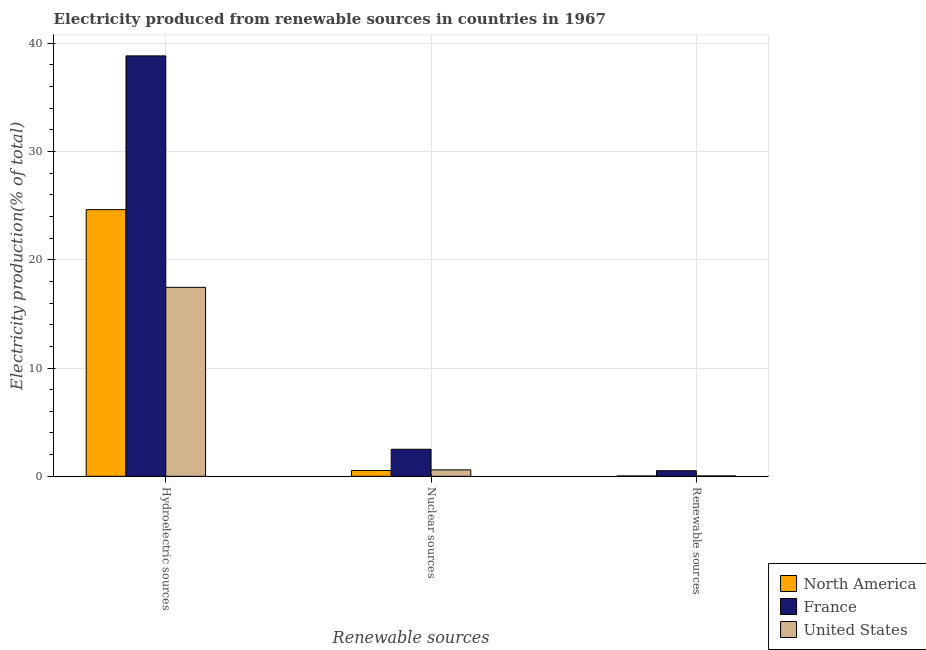Are the number of bars on each tick of the X-axis equal?
Offer a terse response. Yes. What is the label of the 2nd group of bars from the left?
Offer a very short reply. Nuclear sources. What is the percentage of electricity produced by nuclear sources in United States?
Provide a short and direct response. 0.59. Across all countries, what is the maximum percentage of electricity produced by nuclear sources?
Provide a short and direct response. 2.5. Across all countries, what is the minimum percentage of electricity produced by renewable sources?
Offer a terse response. 0.03. In which country was the percentage of electricity produced by nuclear sources minimum?
Offer a very short reply. North America. What is the total percentage of electricity produced by renewable sources in the graph?
Provide a short and direct response. 0.59. What is the difference between the percentage of electricity produced by renewable sources in United States and that in France?
Offer a very short reply. -0.48. What is the difference between the percentage of electricity produced by hydroelectric sources in United States and the percentage of electricity produced by nuclear sources in France?
Ensure brevity in your answer.  14.95. What is the average percentage of electricity produced by nuclear sources per country?
Give a very brief answer. 1.21. What is the difference between the percentage of electricity produced by renewable sources and percentage of electricity produced by nuclear sources in United States?
Provide a short and direct response. -0.56. What is the ratio of the percentage of electricity produced by hydroelectric sources in North America to that in United States?
Offer a very short reply. 1.41. Is the difference between the percentage of electricity produced by nuclear sources in United States and North America greater than the difference between the percentage of electricity produced by renewable sources in United States and North America?
Your response must be concise. Yes. What is the difference between the highest and the second highest percentage of electricity produced by hydroelectric sources?
Your response must be concise. 14.2. What is the difference between the highest and the lowest percentage of electricity produced by renewable sources?
Offer a very short reply. 0.49. In how many countries, is the percentage of electricity produced by hydroelectric sources greater than the average percentage of electricity produced by hydroelectric sources taken over all countries?
Provide a succinct answer. 1. What does the 1st bar from the right in Hydroelectric sources represents?
Your answer should be very brief. United States. Are all the bars in the graph horizontal?
Provide a short and direct response. No. What is the difference between two consecutive major ticks on the Y-axis?
Your answer should be very brief. 10. Does the graph contain any zero values?
Ensure brevity in your answer.  No. How are the legend labels stacked?
Give a very brief answer. Vertical. What is the title of the graph?
Keep it short and to the point. Electricity produced from renewable sources in countries in 1967. Does "Malawi" appear as one of the legend labels in the graph?
Ensure brevity in your answer.  No. What is the label or title of the X-axis?
Offer a terse response. Renewable sources. What is the Electricity production(% of total) in North America in Hydroelectric sources?
Provide a succinct answer. 24.62. What is the Electricity production(% of total) in France in Hydroelectric sources?
Offer a terse response. 38.81. What is the Electricity production(% of total) in United States in Hydroelectric sources?
Provide a short and direct response. 17.45. What is the Electricity production(% of total) in North America in Nuclear sources?
Your response must be concise. 0.54. What is the Electricity production(% of total) in France in Nuclear sources?
Your answer should be compact. 2.5. What is the Electricity production(% of total) in United States in Nuclear sources?
Offer a terse response. 0.59. What is the Electricity production(% of total) in North America in Renewable sources?
Your answer should be compact. 0.03. What is the Electricity production(% of total) in France in Renewable sources?
Your answer should be compact. 0.52. What is the Electricity production(% of total) in United States in Renewable sources?
Provide a short and direct response. 0.04. Across all Renewable sources, what is the maximum Electricity production(% of total) in North America?
Keep it short and to the point. 24.62. Across all Renewable sources, what is the maximum Electricity production(% of total) in France?
Ensure brevity in your answer.  38.81. Across all Renewable sources, what is the maximum Electricity production(% of total) in United States?
Offer a terse response. 17.45. Across all Renewable sources, what is the minimum Electricity production(% of total) of North America?
Provide a succinct answer. 0.03. Across all Renewable sources, what is the minimum Electricity production(% of total) of France?
Give a very brief answer. 0.52. Across all Renewable sources, what is the minimum Electricity production(% of total) of United States?
Offer a very short reply. 0.04. What is the total Electricity production(% of total) in North America in the graph?
Offer a terse response. 25.19. What is the total Electricity production(% of total) of France in the graph?
Ensure brevity in your answer.  41.83. What is the total Electricity production(% of total) of United States in the graph?
Offer a terse response. 18.08. What is the difference between the Electricity production(% of total) of North America in Hydroelectric sources and that in Nuclear sources?
Your response must be concise. 24.08. What is the difference between the Electricity production(% of total) in France in Hydroelectric sources and that in Nuclear sources?
Make the answer very short. 36.32. What is the difference between the Electricity production(% of total) of United States in Hydroelectric sources and that in Nuclear sources?
Offer a very short reply. 16.85. What is the difference between the Electricity production(% of total) in North America in Hydroelectric sources and that in Renewable sources?
Offer a terse response. 24.59. What is the difference between the Electricity production(% of total) in France in Hydroelectric sources and that in Renewable sources?
Ensure brevity in your answer.  38.3. What is the difference between the Electricity production(% of total) of United States in Hydroelectric sources and that in Renewable sources?
Ensure brevity in your answer.  17.41. What is the difference between the Electricity production(% of total) of North America in Nuclear sources and that in Renewable sources?
Your answer should be compact. 0.5. What is the difference between the Electricity production(% of total) in France in Nuclear sources and that in Renewable sources?
Make the answer very short. 1.98. What is the difference between the Electricity production(% of total) in United States in Nuclear sources and that in Renewable sources?
Keep it short and to the point. 0.56. What is the difference between the Electricity production(% of total) of North America in Hydroelectric sources and the Electricity production(% of total) of France in Nuclear sources?
Your answer should be very brief. 22.12. What is the difference between the Electricity production(% of total) in North America in Hydroelectric sources and the Electricity production(% of total) in United States in Nuclear sources?
Your answer should be compact. 24.02. What is the difference between the Electricity production(% of total) of France in Hydroelectric sources and the Electricity production(% of total) of United States in Nuclear sources?
Offer a very short reply. 38.22. What is the difference between the Electricity production(% of total) in North America in Hydroelectric sources and the Electricity production(% of total) in France in Renewable sources?
Keep it short and to the point. 24.1. What is the difference between the Electricity production(% of total) in North America in Hydroelectric sources and the Electricity production(% of total) in United States in Renewable sources?
Provide a short and direct response. 24.58. What is the difference between the Electricity production(% of total) of France in Hydroelectric sources and the Electricity production(% of total) of United States in Renewable sources?
Keep it short and to the point. 38.78. What is the difference between the Electricity production(% of total) of North America in Nuclear sources and the Electricity production(% of total) of France in Renewable sources?
Provide a succinct answer. 0.02. What is the difference between the Electricity production(% of total) in North America in Nuclear sources and the Electricity production(% of total) in United States in Renewable sources?
Provide a succinct answer. 0.5. What is the difference between the Electricity production(% of total) of France in Nuclear sources and the Electricity production(% of total) of United States in Renewable sources?
Provide a succinct answer. 2.46. What is the average Electricity production(% of total) of North America per Renewable sources?
Give a very brief answer. 8.4. What is the average Electricity production(% of total) in France per Renewable sources?
Offer a terse response. 13.94. What is the average Electricity production(% of total) in United States per Renewable sources?
Keep it short and to the point. 6.03. What is the difference between the Electricity production(% of total) of North America and Electricity production(% of total) of France in Hydroelectric sources?
Provide a succinct answer. -14.2. What is the difference between the Electricity production(% of total) of North America and Electricity production(% of total) of United States in Hydroelectric sources?
Keep it short and to the point. 7.17. What is the difference between the Electricity production(% of total) of France and Electricity production(% of total) of United States in Hydroelectric sources?
Your answer should be very brief. 21.37. What is the difference between the Electricity production(% of total) of North America and Electricity production(% of total) of France in Nuclear sources?
Your answer should be very brief. -1.96. What is the difference between the Electricity production(% of total) of North America and Electricity production(% of total) of United States in Nuclear sources?
Your response must be concise. -0.06. What is the difference between the Electricity production(% of total) in France and Electricity production(% of total) in United States in Nuclear sources?
Offer a very short reply. 1.9. What is the difference between the Electricity production(% of total) of North America and Electricity production(% of total) of France in Renewable sources?
Provide a succinct answer. -0.48. What is the difference between the Electricity production(% of total) in North America and Electricity production(% of total) in United States in Renewable sources?
Provide a short and direct response. -0. What is the difference between the Electricity production(% of total) of France and Electricity production(% of total) of United States in Renewable sources?
Make the answer very short. 0.48. What is the ratio of the Electricity production(% of total) of North America in Hydroelectric sources to that in Nuclear sources?
Provide a short and direct response. 45.92. What is the ratio of the Electricity production(% of total) of France in Hydroelectric sources to that in Nuclear sources?
Offer a terse response. 15.53. What is the ratio of the Electricity production(% of total) of United States in Hydroelectric sources to that in Nuclear sources?
Make the answer very short. 29.33. What is the ratio of the Electricity production(% of total) of North America in Hydroelectric sources to that in Renewable sources?
Offer a very short reply. 755.58. What is the ratio of the Electricity production(% of total) of France in Hydroelectric sources to that in Renewable sources?
Offer a terse response. 74.99. What is the ratio of the Electricity production(% of total) in United States in Hydroelectric sources to that in Renewable sources?
Provide a succinct answer. 473.04. What is the ratio of the Electricity production(% of total) of North America in Nuclear sources to that in Renewable sources?
Ensure brevity in your answer.  16.45. What is the ratio of the Electricity production(% of total) of France in Nuclear sources to that in Renewable sources?
Ensure brevity in your answer.  4.83. What is the ratio of the Electricity production(% of total) of United States in Nuclear sources to that in Renewable sources?
Offer a terse response. 16.13. What is the difference between the highest and the second highest Electricity production(% of total) in North America?
Ensure brevity in your answer.  24.08. What is the difference between the highest and the second highest Electricity production(% of total) in France?
Offer a terse response. 36.32. What is the difference between the highest and the second highest Electricity production(% of total) in United States?
Your response must be concise. 16.85. What is the difference between the highest and the lowest Electricity production(% of total) in North America?
Provide a succinct answer. 24.59. What is the difference between the highest and the lowest Electricity production(% of total) in France?
Ensure brevity in your answer.  38.3. What is the difference between the highest and the lowest Electricity production(% of total) in United States?
Keep it short and to the point. 17.41. 